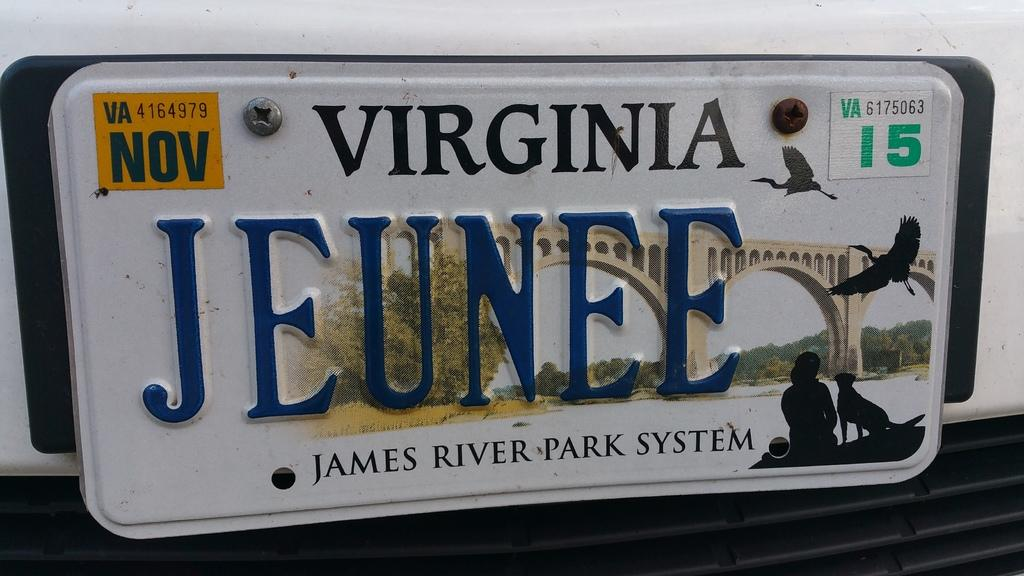<image>
Summarize the visual content of the image. A Virginia license plate that reads Jeunee with a picture of a bridge in the background, above the words James River Park System.. 